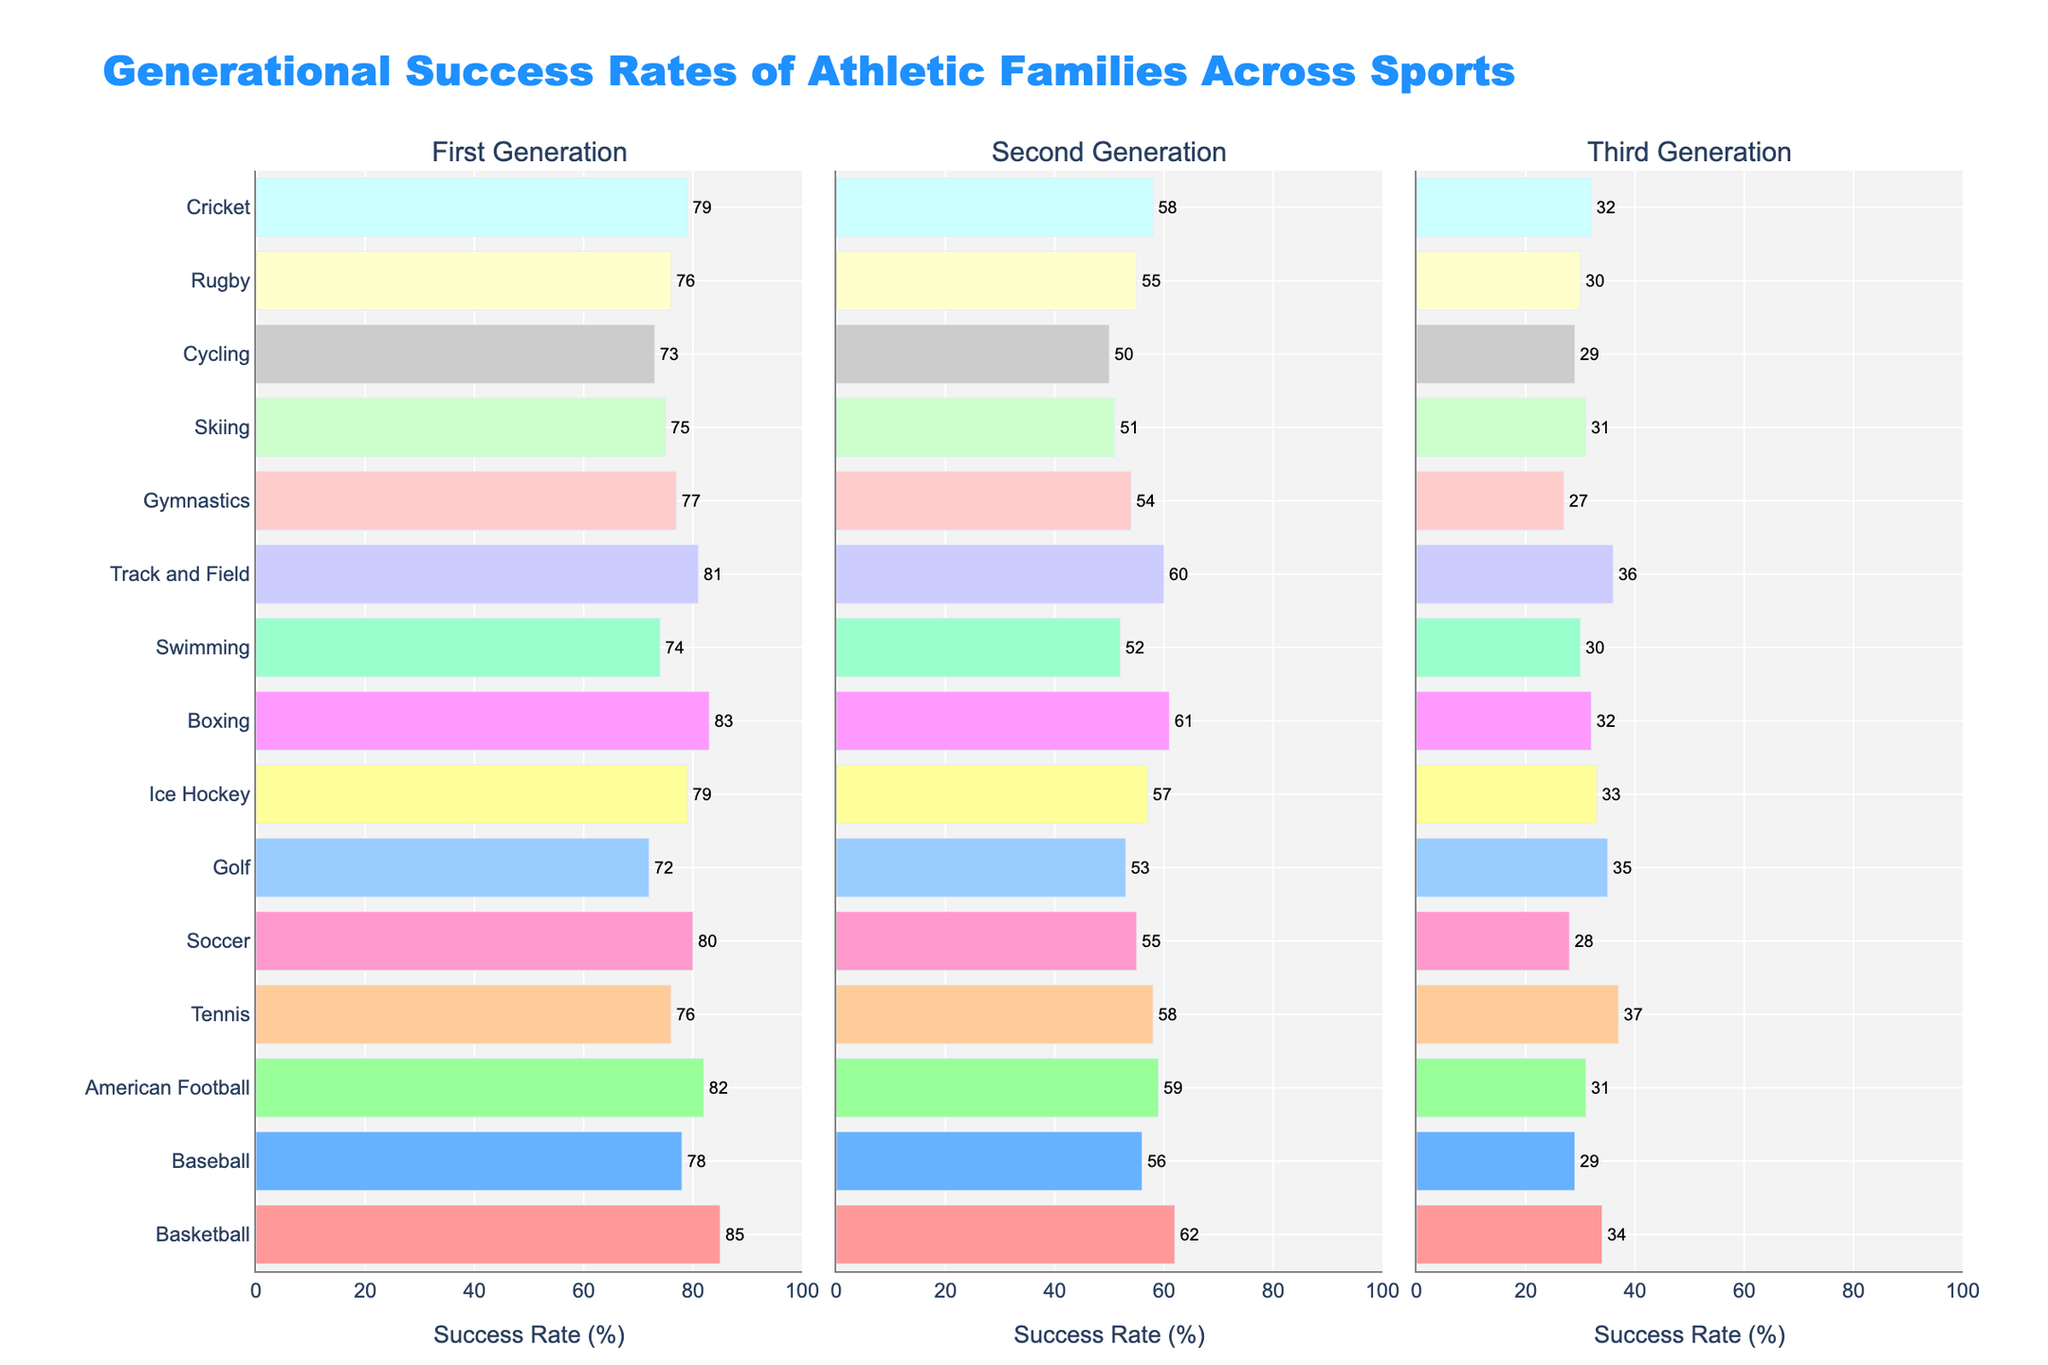what sport has the highest first-generation success rate? Looking at the bars in the first subplot for the "First Generation" success rates, the tallest bar indicates the sport with the highest rate. In this case, the tallest bar belongs to Basketball, which has a 85% success rate.
Answer: Basketball which sport has the lowest second-generation success rate? Referring to the bars in the second subplot for the "Second Generation" success rates, the shortest bar indicates the sport with the lowest rate. In this case, the shortest bar belongs to Cycling, which has a 50% success rate.
Answer: Cycling how does the third-generation success rate of Tennis compare to the second-generation success rate of Tennis? Looking at the lengths of the bars for Tennis in the "Second Generation" and "Third Generation" subplots, we see that the third-generation success rate (37%) is smaller than the second-generation success rate (58%).
Answer: The third-generation success rate is lower what is the average success rate across all three generations for Ice Hockey? First, we find the success rates for Ice Hockey: 79% (First Generation), 57% (Second Generation), and 33% (Third Generation). Sum these rates: 79 + 57 + 33 = 169. Divide by 3 to get the average: 169 / 3 ≈ 56.33
Answer: 56.33% which generation shows the most significant decline within American Football from one generation to the next? Reviewing the "American Football" bars, the transition from "First Generation" to "Second Generation" shows a decline from 82% to 59%, a drop of 23%. From "Second Generation" to "Third Generation," the decline is from 59% to 31%, a drop of 28%. The more significant decline is between the second and third generations (59% - 31% = 28%).
Answer: Second to Third Generation what is the combined success rate for first and second generations in Soccer? The success rates for Soccer in the "First Generation" and "Second Generation" are 80% and 55% respectively. Adding these values gives a combined success rate: 80 + 55 = 135%.
Answer: 135% which sport shows the least difference between first and third-generation success rates? We calculate the differences for each sport by subtracting the third-generation rate from the first-generation rate. The smallest difference:
Basketball: 85 - 34 = 51
Baseball: 78 - 29 = 49
American Football: 82 - 31 = 51
Tennis: 76 - 37 = 39
Soccer: 80 - 28 = 52
Golf: 72 - 35 = 37
Ice Hockey: 79 - 33 = 46
Boxing: 83 - 32 = 51
Swimming: 74 - 30 = 44
Track and Field: 81 - 36 = 45
Gymnastics: 77 - 27 = 50
Skiing: 75 - 31 = 44
Cycling: 73 - 29 = 44
Rugby: 76 - 30 = 46
Cricket: 79 - 32 = 47
The smallest difference is for Golf: 37.
Answer: Golf which sport has a higher second-generation success rate, Cricket or Tennis? Observing the heights of the bars in the "Second Generation" subplot for Cricket and Tennis, Cricket has a 58% success rate, while Tennis also has a 58% success rate. Therefore, they are equal.
Answer: They are equal for which sport is the second generation's success rate more than double the third generation's? Comparing the success rates for the "Second Generation" and "Third Generation" subplots reveals that for Soccer, the second generation's success rate is 55%, and the third generation's success rate is 28%. 55% is more than double 28%.
Answer: Soccer what is the difference in third-generation success rates between Boxing and Gymnastics? Looking at the "Third Generation" subplot, Boxing has a 32% success rate, and Gymnastics has a 27% success rate. The difference between them is 32 - 27 = 5%.
Answer: 5% 